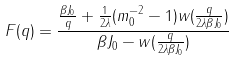Convert formula to latex. <formula><loc_0><loc_0><loc_500><loc_500>F ( q ) = { \frac { { \frac { \beta J _ { 0 } } { q } } + { \frac { 1 } { 2 \lambda } } ( m _ { 0 } ^ { - 2 } - 1 ) w ( { \frac { q } { 2 \lambda \beta J _ { 0 } } } ) } { \beta J _ { 0 } - w ( { \frac { q } { 2 \lambda \beta J _ { 0 } } } ) } }</formula> 